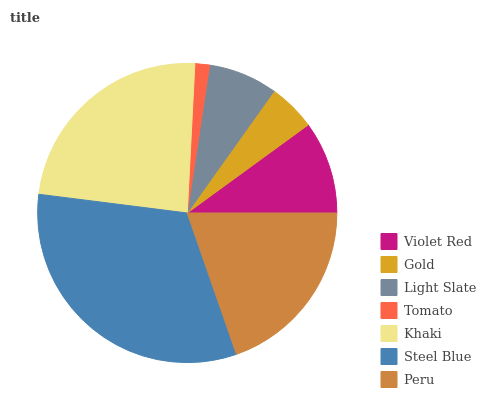Is Tomato the minimum?
Answer yes or no. Yes. Is Steel Blue the maximum?
Answer yes or no. Yes. Is Gold the minimum?
Answer yes or no. No. Is Gold the maximum?
Answer yes or no. No. Is Violet Red greater than Gold?
Answer yes or no. Yes. Is Gold less than Violet Red?
Answer yes or no. Yes. Is Gold greater than Violet Red?
Answer yes or no. No. Is Violet Red less than Gold?
Answer yes or no. No. Is Violet Red the high median?
Answer yes or no. Yes. Is Violet Red the low median?
Answer yes or no. Yes. Is Gold the high median?
Answer yes or no. No. Is Tomato the low median?
Answer yes or no. No. 